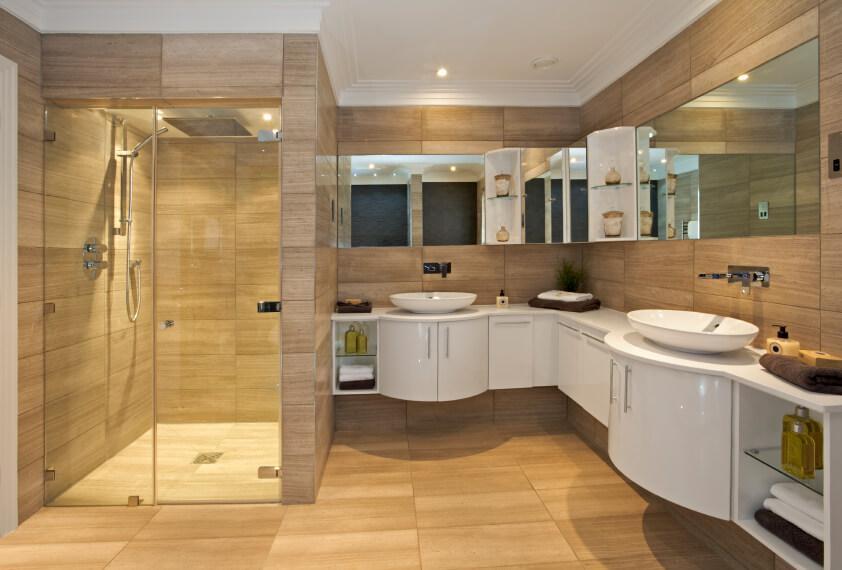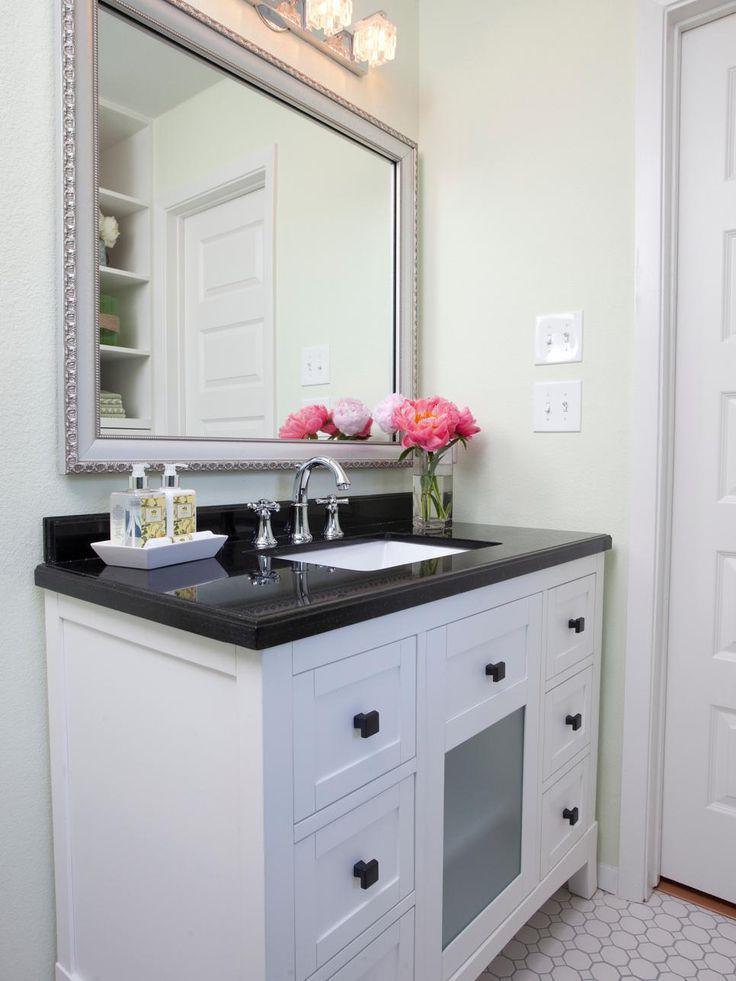The first image is the image on the left, the second image is the image on the right. For the images displayed, is the sentence "An area with two bathroom sinks and a glass shower unit can be seen in one image, while the other image shows a single sink and surrounding cabinetry." factually correct? Answer yes or no. Yes. The first image is the image on the left, the second image is the image on the right. For the images displayed, is the sentence "Right image shows only one rectangular mirror hanging over only one vanity with one sink, in a room with no bathtub visible." factually correct? Answer yes or no. Yes. 